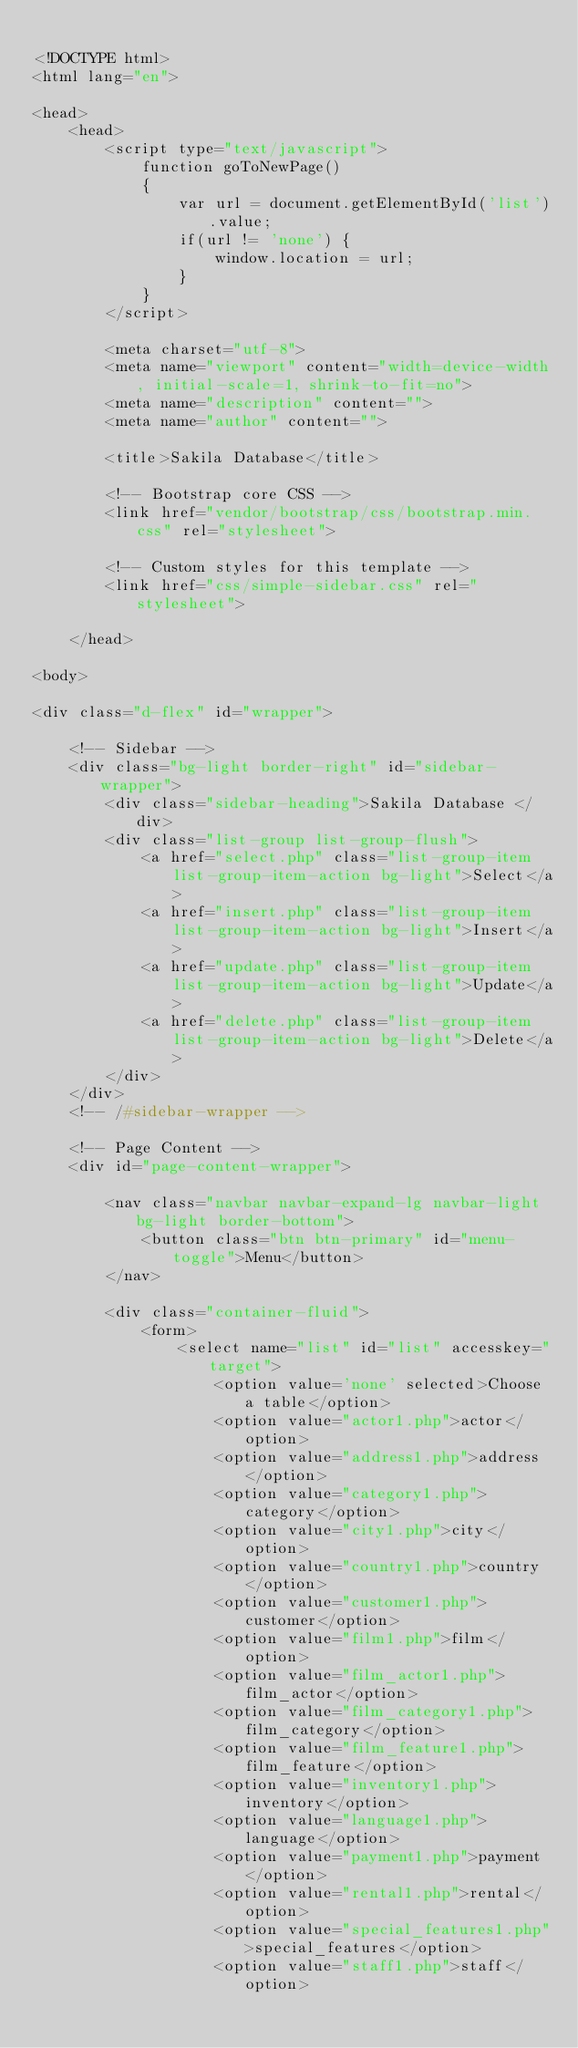<code> <loc_0><loc_0><loc_500><loc_500><_PHP_>
<!DOCTYPE html>
<html lang="en">

<head>
    <head>
        <script type="text/javascript">
            function goToNewPage()
            {
                var url = document.getElementById('list').value;
                if(url != 'none') {
                    window.location = url;
                }
            }
        </script>

        <meta charset="utf-8">
        <meta name="viewport" content="width=device-width, initial-scale=1, shrink-to-fit=no">
        <meta name="description" content="">
        <meta name="author" content="">

        <title>Sakila Database</title>

        <!-- Bootstrap core CSS -->
        <link href="vendor/bootstrap/css/bootstrap.min.css" rel="stylesheet">

        <!-- Custom styles for this template -->
        <link href="css/simple-sidebar.css" rel="stylesheet">

    </head>

<body>

<div class="d-flex" id="wrapper">

    <!-- Sidebar -->
    <div class="bg-light border-right" id="sidebar-wrapper">
        <div class="sidebar-heading">Sakila Database </div>
        <div class="list-group list-group-flush">
            <a href="select.php" class="list-group-item list-group-item-action bg-light">Select</a>
            <a href="insert.php" class="list-group-item list-group-item-action bg-light">Insert</a>
            <a href="update.php" class="list-group-item list-group-item-action bg-light">Update</a>
            <a href="delete.php" class="list-group-item list-group-item-action bg-light">Delete</a>
        </div>
    </div>
    <!-- /#sidebar-wrapper -->

    <!-- Page Content -->
    <div id="page-content-wrapper">

        <nav class="navbar navbar-expand-lg navbar-light bg-light border-bottom">
            <button class="btn btn-primary" id="menu-toggle">Menu</button>
        </nav>

        <div class="container-fluid">
            <form>
                <select name="list" id="list" accesskey="target">
                    <option value='none' selected>Choose a table</option>
                    <option value="actor1.php">actor</option>
                    <option value="address1.php">address</option>
                    <option value="category1.php">category</option>
                    <option value="city1.php">city</option>
                    <option value="country1.php">country</option>
                    <option value="customer1.php">customer</option>
                    <option value="film1.php">film</option>
                    <option value="film_actor1.php">film_actor</option>
                    <option value="film_category1.php">film_category</option>
                    <option value="film_feature1.php">film_feature</option>
                    <option value="inventory1.php">inventory</option>
                    <option value="language1.php">language</option>
                    <option value="payment1.php">payment</option>
                    <option value="rental1.php">rental</option>
                    <option value="special_features1.php">special_features</option>
                    <option value="staff1.php">staff</option></code> 